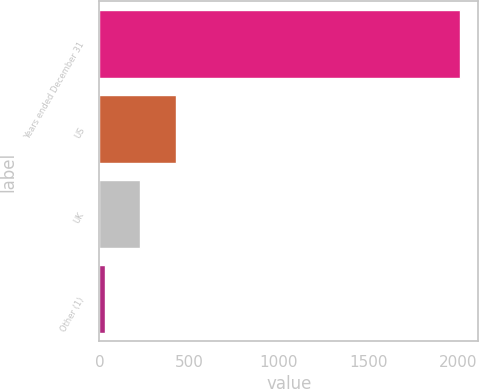Convert chart. <chart><loc_0><loc_0><loc_500><loc_500><bar_chart><fcel>Years ended December 31<fcel>US<fcel>UK<fcel>Other (1)<nl><fcel>2014<fcel>426.8<fcel>228.4<fcel>30<nl></chart> 